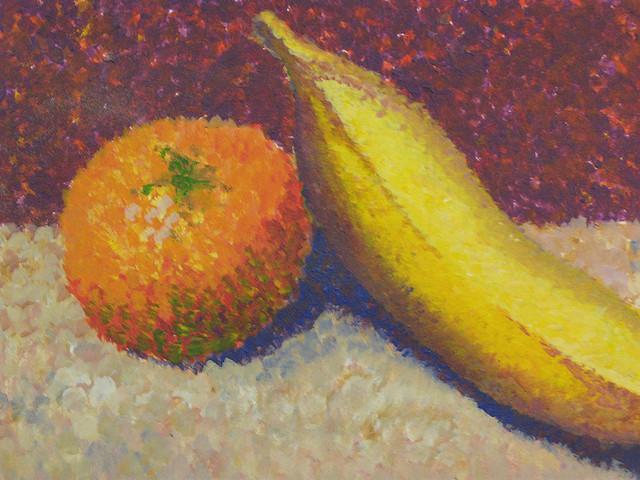Does the caption "The banana is on the orange." correctly depict the image?
Answer yes or no. No. Does the description: "The banana is at the left side of the orange." accurately reflect the image?
Answer yes or no. No. 